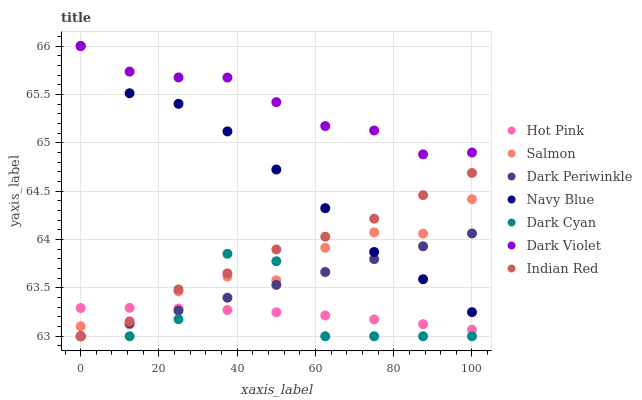Does Hot Pink have the minimum area under the curve?
Answer yes or no. Yes. Does Dark Violet have the maximum area under the curve?
Answer yes or no. Yes. Does Salmon have the minimum area under the curve?
Answer yes or no. No. Does Salmon have the maximum area under the curve?
Answer yes or no. No. Is Dark Periwinkle the smoothest?
Answer yes or no. Yes. Is Dark Cyan the roughest?
Answer yes or no. Yes. Is Hot Pink the smoothest?
Answer yes or no. No. Is Hot Pink the roughest?
Answer yes or no. No. Does Indian Red have the lowest value?
Answer yes or no. Yes. Does Hot Pink have the lowest value?
Answer yes or no. No. Does Dark Violet have the highest value?
Answer yes or no. Yes. Does Salmon have the highest value?
Answer yes or no. No. Is Dark Cyan less than Dark Violet?
Answer yes or no. Yes. Is Navy Blue greater than Dark Cyan?
Answer yes or no. Yes. Does Dark Periwinkle intersect Dark Cyan?
Answer yes or no. Yes. Is Dark Periwinkle less than Dark Cyan?
Answer yes or no. No. Is Dark Periwinkle greater than Dark Cyan?
Answer yes or no. No. Does Dark Cyan intersect Dark Violet?
Answer yes or no. No. 